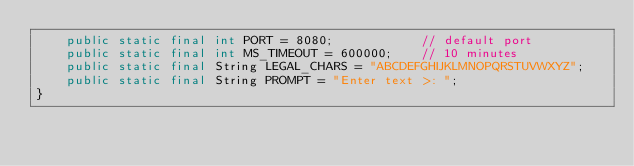Convert code to text. <code><loc_0><loc_0><loc_500><loc_500><_Java_>    public static final int PORT = 8080;            // default port
    public static final int MS_TIMEOUT = 600000;    // 10 minutes
    public static final String LEGAL_CHARS = "ABCDEFGHIJKLMNOPQRSTUVWXYZ";
    public static final String PROMPT = "Enter text >: ";
}
</code> 